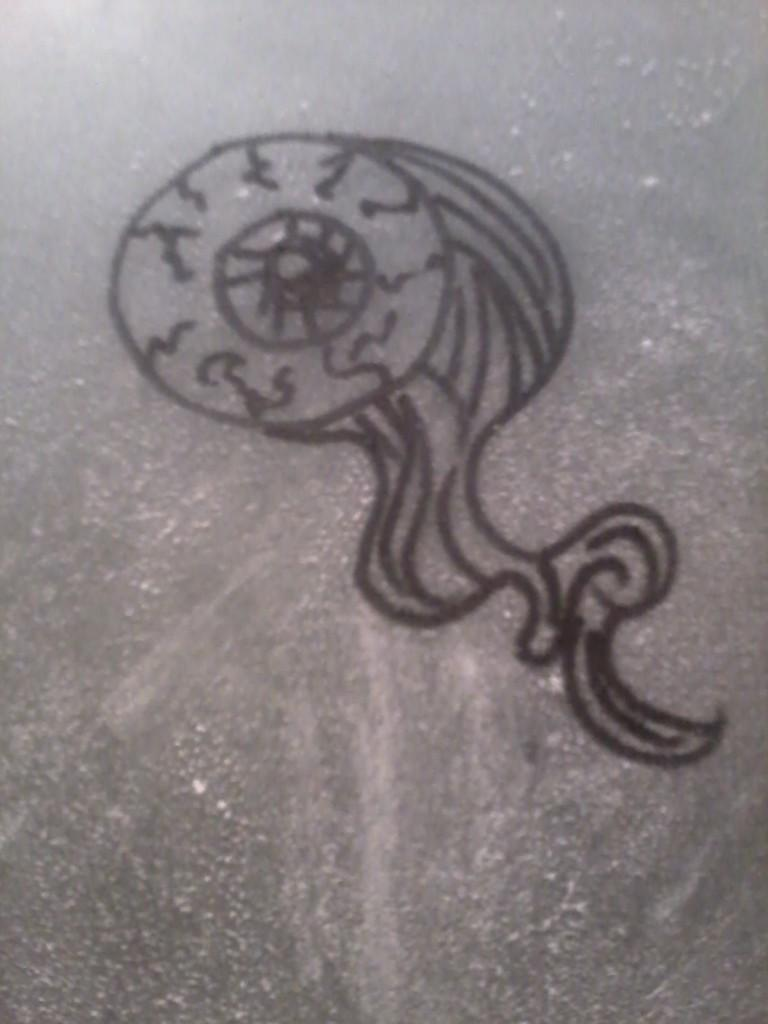What is depicted on the surface in the image? There is a black painting on the surface. What type of straw is used to create the painting in the image? There is no straw present in the image, as the painting is black and does not involve the use of straws. 